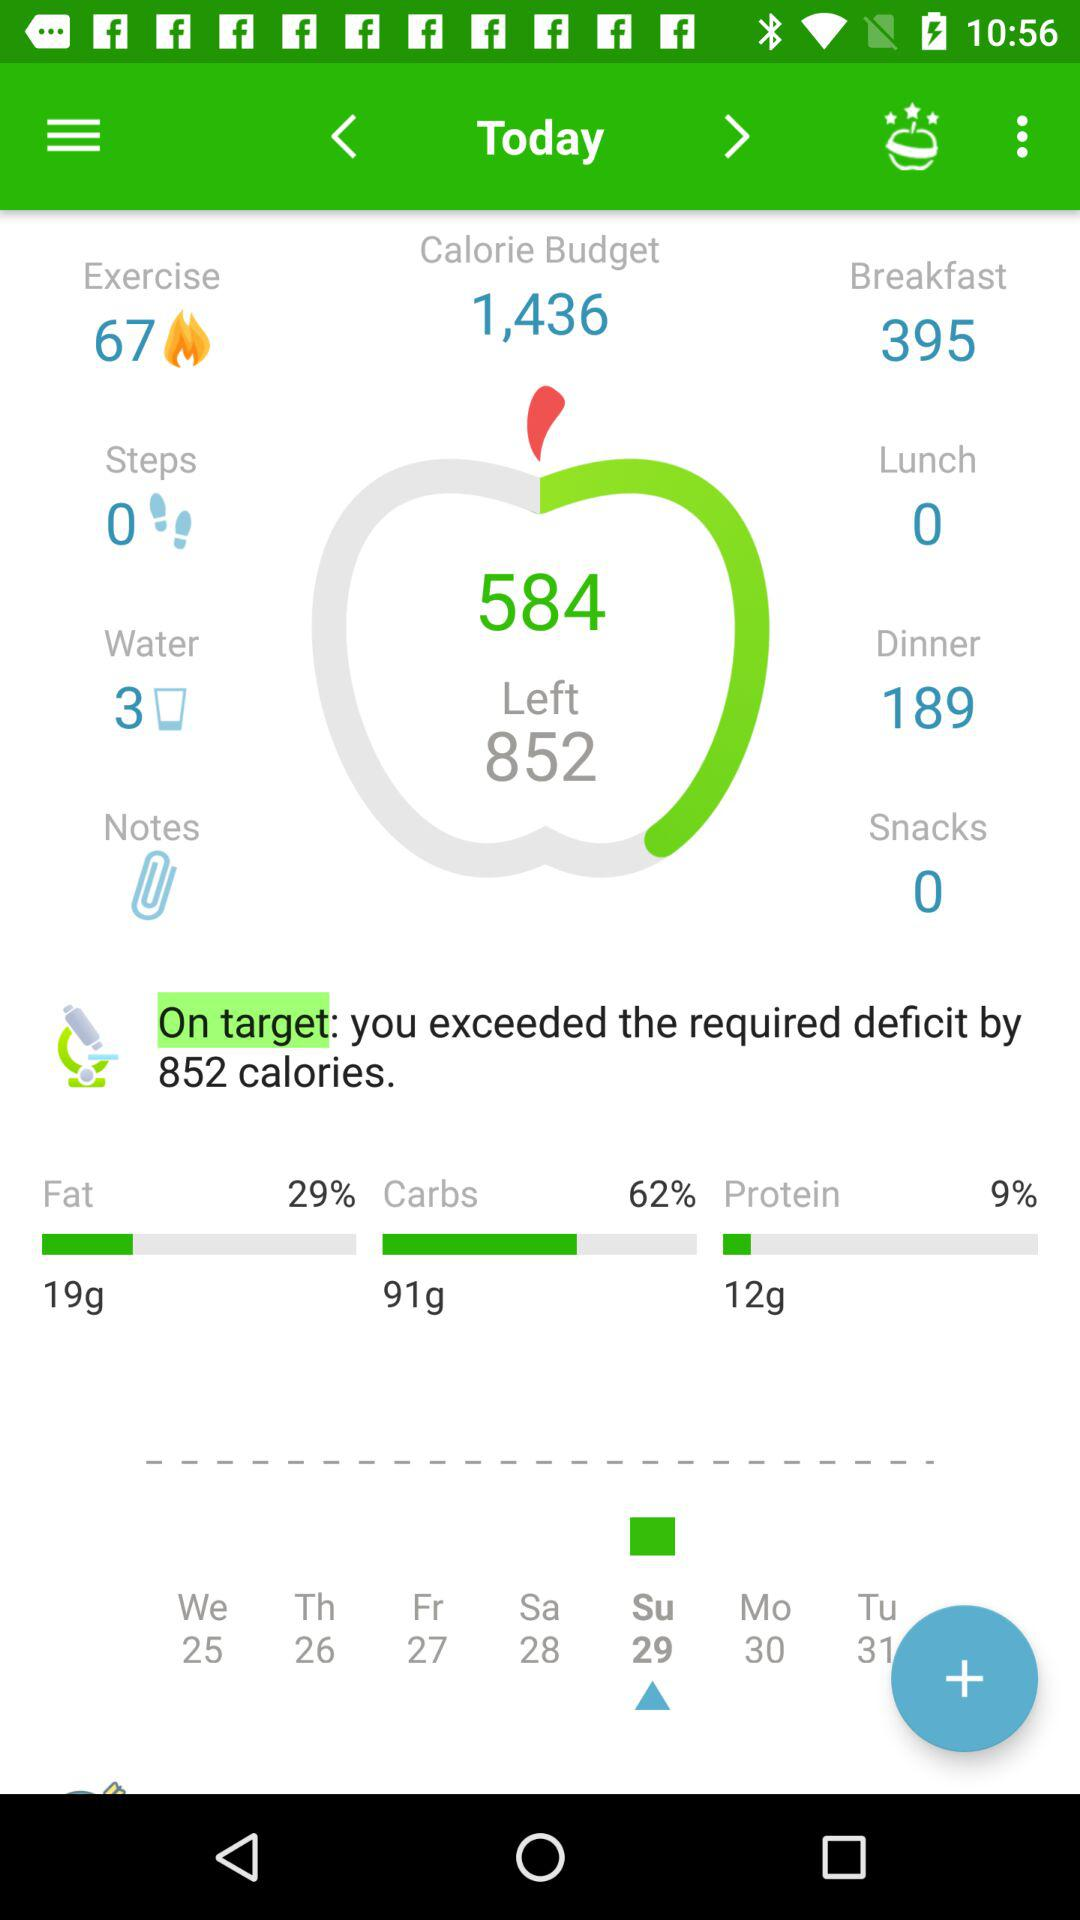What is the number of snacks? The snack number is 0. 